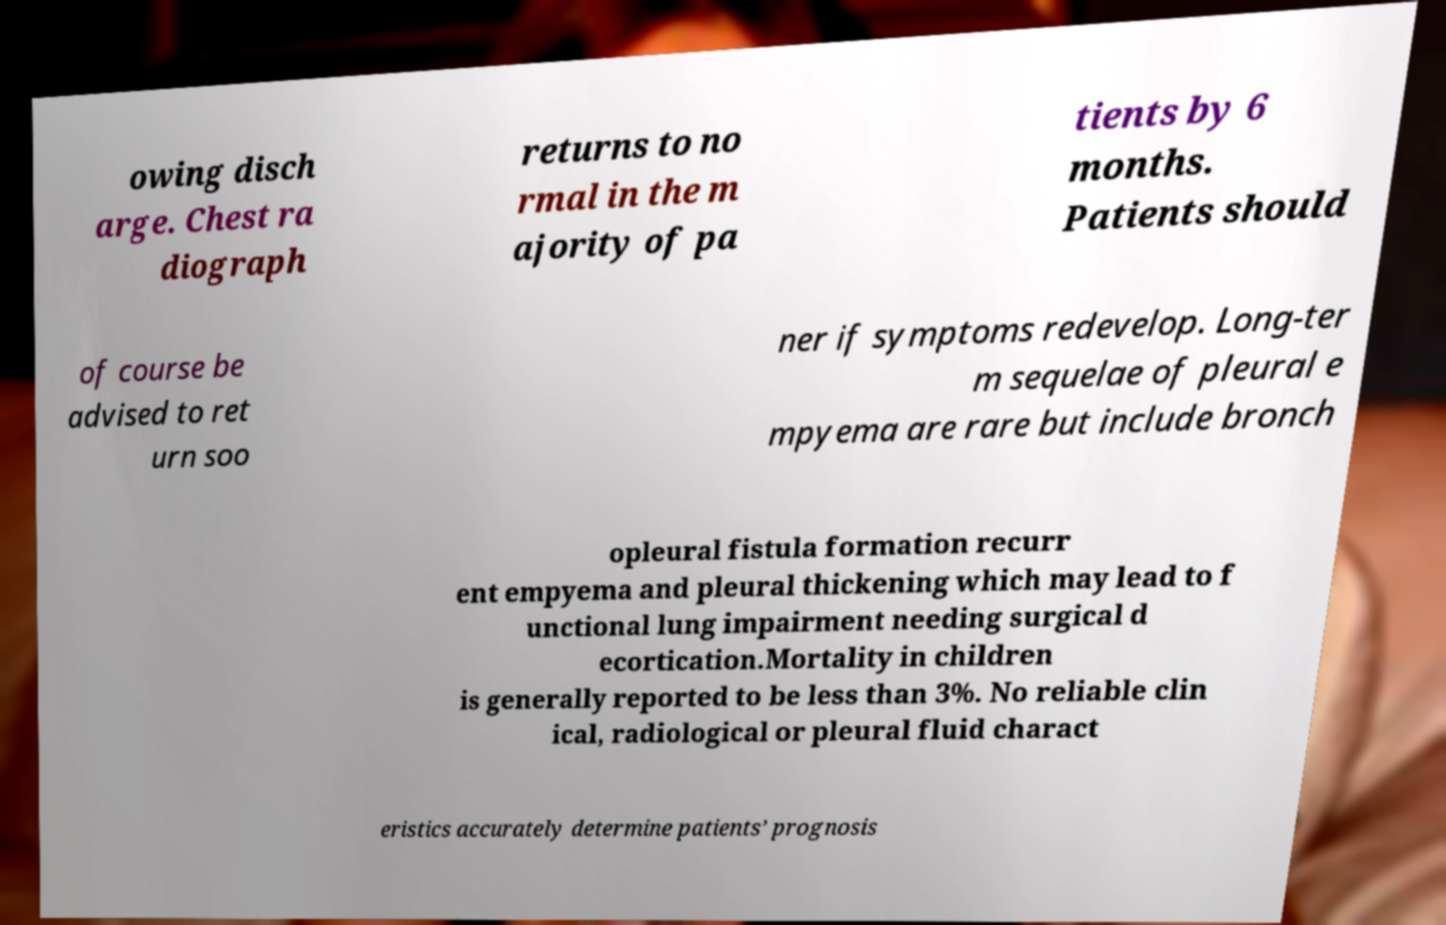What messages or text are displayed in this image? I need them in a readable, typed format. owing disch arge. Chest ra diograph returns to no rmal in the m ajority of pa tients by 6 months. Patients should of course be advised to ret urn soo ner if symptoms redevelop. Long-ter m sequelae of pleural e mpyema are rare but include bronch opleural fistula formation recurr ent empyema and pleural thickening which may lead to f unctional lung impairment needing surgical d ecortication.Mortality in children is generally reported to be less than 3%. No reliable clin ical, radiological or pleural fluid charact eristics accurately determine patients’ prognosis 